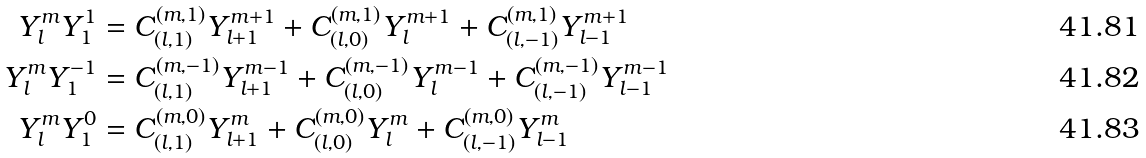Convert formula to latex. <formula><loc_0><loc_0><loc_500><loc_500>Y _ { l } ^ { m } Y _ { 1 } ^ { 1 } & = C _ { ( l , 1 ) } ^ { ( m , 1 ) } Y _ { l + 1 } ^ { m + 1 } + C _ { ( l , 0 ) } ^ { ( m , 1 ) } Y _ { l } ^ { m + 1 } + C _ { ( l , - 1 ) } ^ { ( m , 1 ) } Y _ { l - 1 } ^ { m + 1 } \\ Y _ { l } ^ { m } Y _ { 1 } ^ { - 1 } & = C _ { ( l , 1 ) } ^ { ( m , - 1 ) } Y _ { l + 1 } ^ { m - 1 } + C _ { ( l , 0 ) } ^ { ( m , - 1 ) } Y _ { l } ^ { m - 1 } + C _ { ( l , - 1 ) } ^ { ( m , - 1 ) } Y _ { l - 1 } ^ { m - 1 } \\ Y _ { l } ^ { m } Y _ { 1 } ^ { 0 } & = C _ { ( l , 1 ) } ^ { ( m , 0 ) } Y _ { l + 1 } ^ { m } + C _ { ( l , 0 ) } ^ { ( m , 0 ) } Y _ { l } ^ { m } + C _ { ( l , - 1 ) } ^ { ( m , 0 ) } Y _ { l - 1 } ^ { m }</formula> 